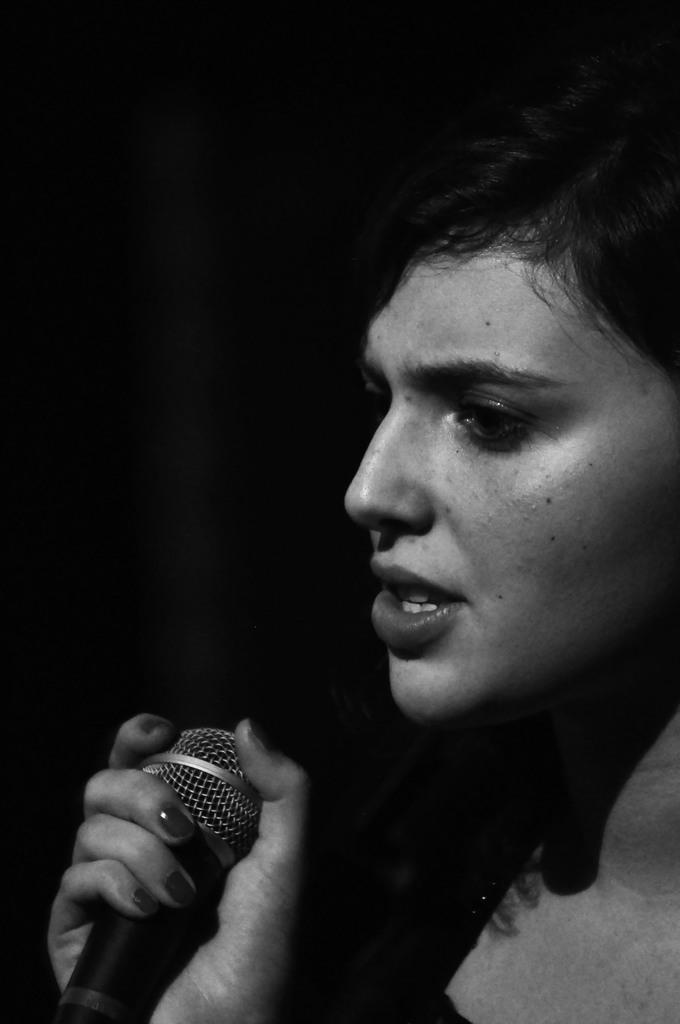Who is the main subject in the image? There is a lady in the image. Where is the lady located in the image? The lady is on the right side of the image. What is the lady holding in her hand? The lady is holding a microphone in her hand. What type of bells can be heard ringing in the background of the image? There are no bells present in the image, nor is there any sound or audio information provided. 